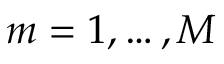Convert formula to latex. <formula><loc_0><loc_0><loc_500><loc_500>m = 1 , \dots , M</formula> 